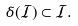<formula> <loc_0><loc_0><loc_500><loc_500>\delta ( \mathcal { I } ) \subset \mathcal { I } .</formula> 